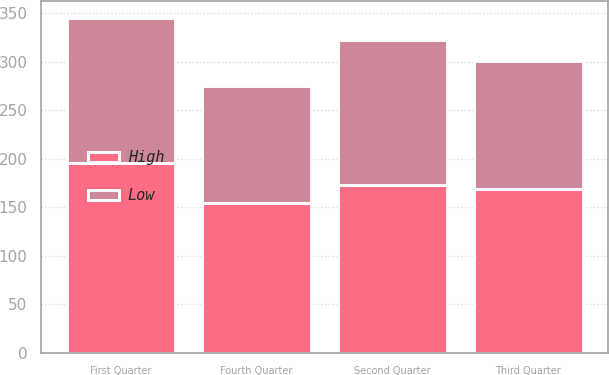<chart> <loc_0><loc_0><loc_500><loc_500><stacked_bar_chart><ecel><fcel>First Quarter<fcel>Second Quarter<fcel>Third Quarter<fcel>Fourth Quarter<nl><fcel>High<fcel>195.41<fcel>173.44<fcel>168.94<fcel>153.99<nl><fcel>Low<fcel>149.87<fcel>148.91<fcel>131.53<fcel>121.36<nl></chart> 